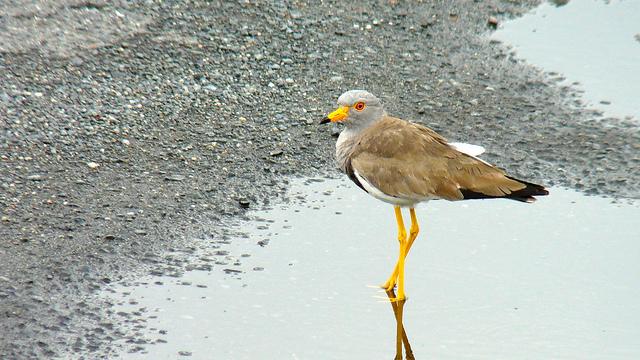What color is the puddle the bird is standing in?
Keep it brief. Gray. Is this bird's feet wet?
Concise answer only. Yes. Does this bird's beak and legs match in color?
Short answer required. Yes. 